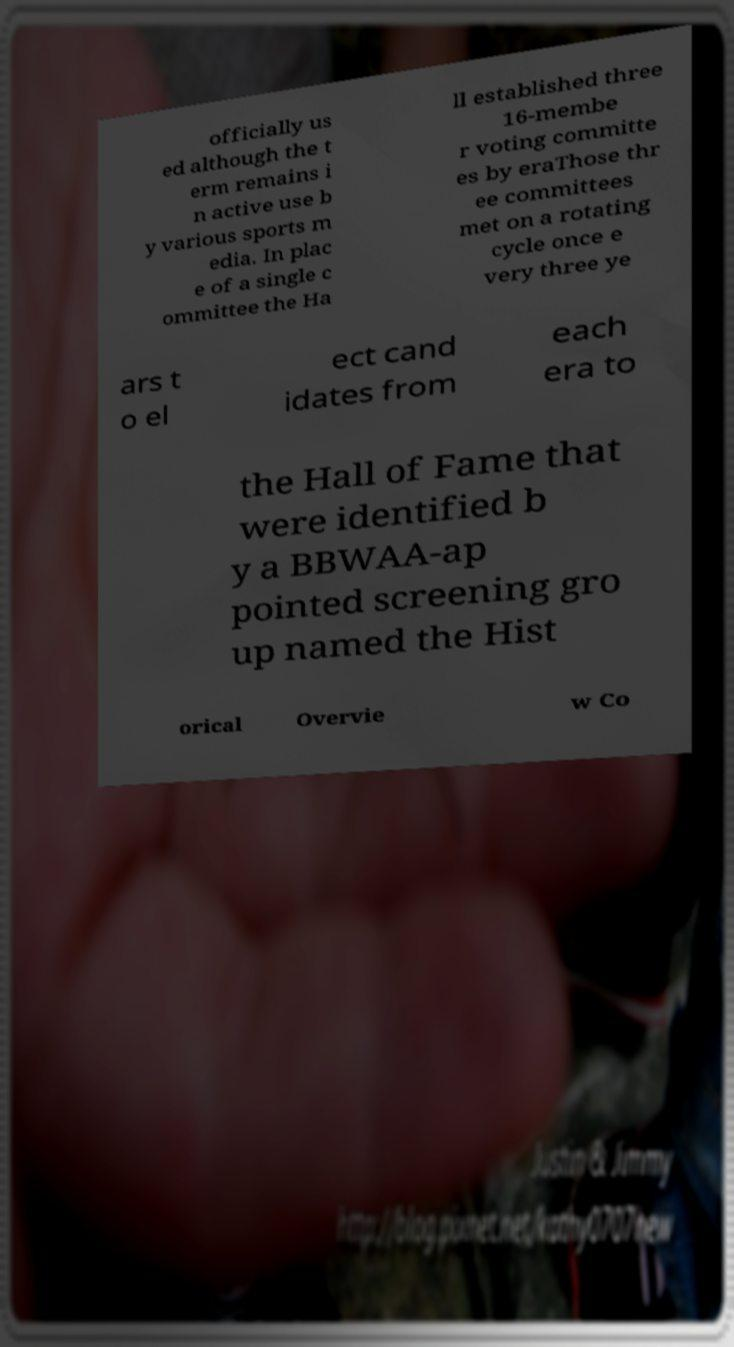Can you accurately transcribe the text from the provided image for me? officially us ed although the t erm remains i n active use b y various sports m edia. In plac e of a single c ommittee the Ha ll established three 16-membe r voting committe es by eraThose thr ee committees met on a rotating cycle once e very three ye ars t o el ect cand idates from each era to the Hall of Fame that were identified b y a BBWAA-ap pointed screening gro up named the Hist orical Overvie w Co 